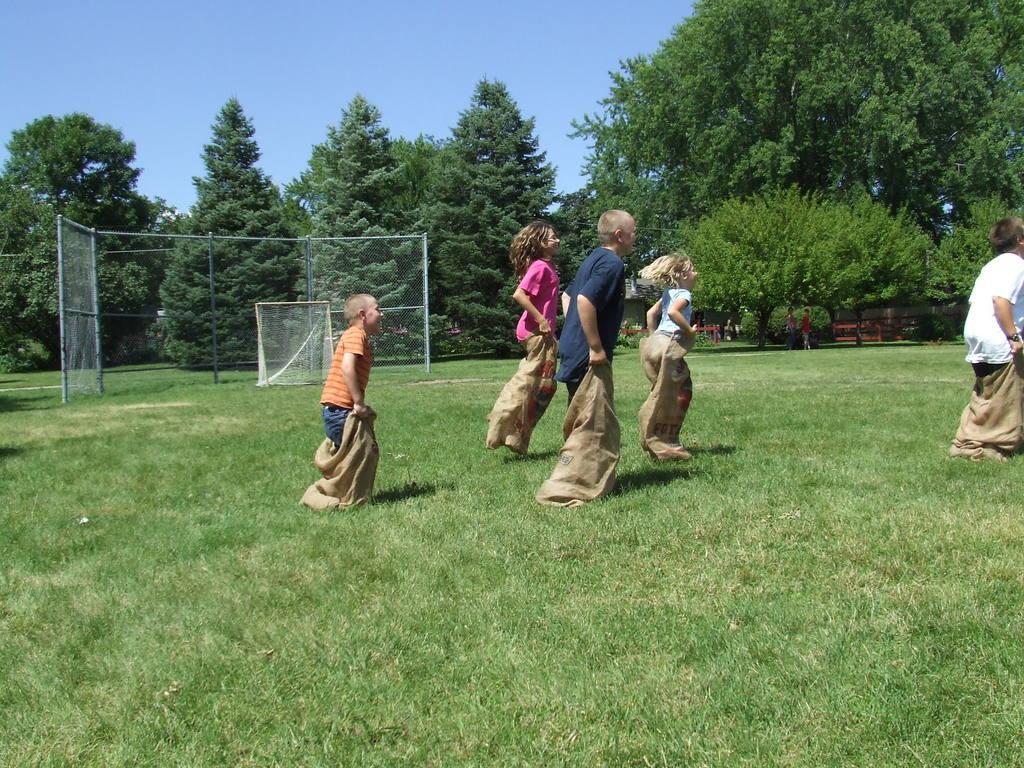Could you give a brief overview of what you see in this image? In this image can see an open grass ground and on it I can see few children are doing sack race. In the background I can see few poles, number of trees, few people and the sky. 